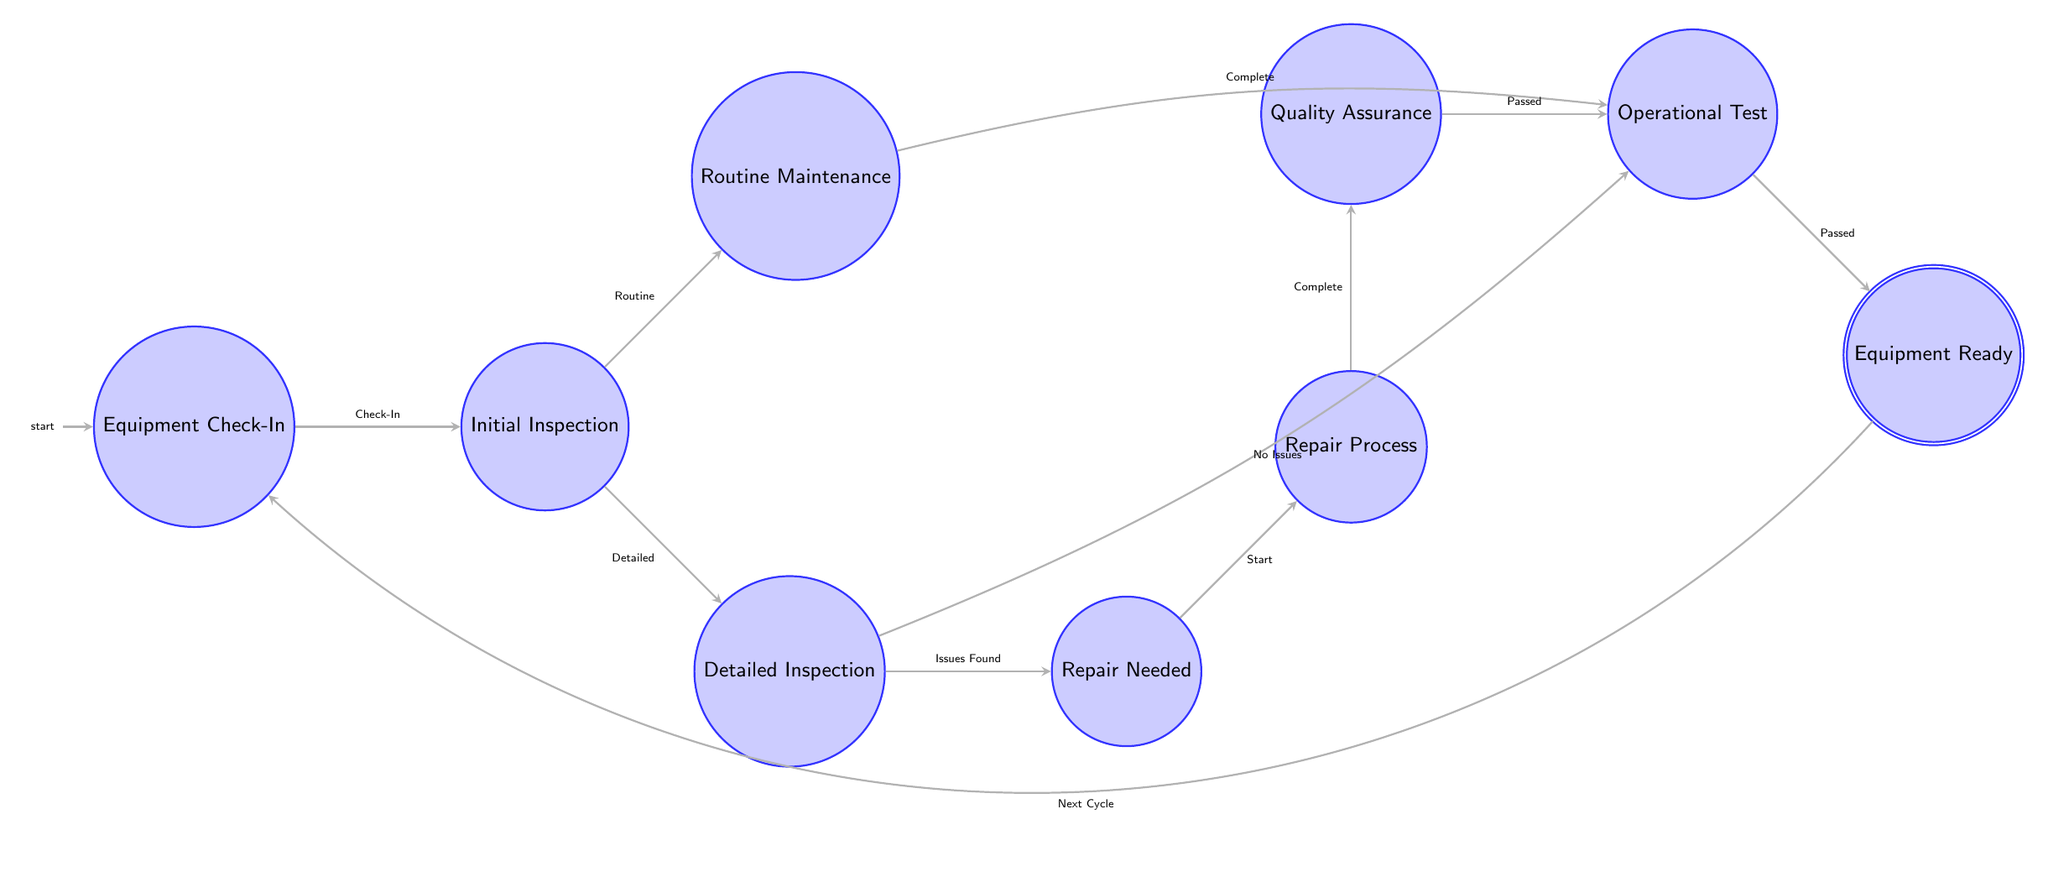What is the first state in the equipment maintenance schedule? The first state is labeled "Equipment Check-In," which is where the process begins according to the diagram.
Answer: Equipment Check-In How many states are there in total? By counting each distinct state in the diagram, including the starting and accepting states, we find that there are nine states.
Answer: Nine What transition occurs after "Routine Maintenance"? The transition that occurs after "Routine Maintenance" is labeled "Complete," which leads to the "Operational Test" state.
Answer: Operational Test What state does "Repair Process" lead to? The "Repair Process" leads to the state "Quality Assurance," as indicated by the transition from one to the other.
Answer: Quality Assurance What are the two potential outcomes after "Detailed Inspection"? After "Detailed Inspection," the possible outcomes are "Repair Needed" and "Operational Test," depending on whether issues were found or not.
Answer: Repair Needed, Operational Test Which state is reached after the "Operational Test" is complete? After the "Operational Test" is complete, the next state reached is "Equipment Ready," as shown in the transition line to the acceptance state.
Answer: Equipment Ready If an issue is found during "Detailed Inspection," what state is entered next? If there are issues found during the "Detailed Inspection," the next state to be entered is "Repair Needed," leading into the repair process.
Answer: Repair Needed What is the purpose of the "Quality Assurance" state? The purpose of the "Quality Assurance" state is to ensure that whatever repairs or maintenance has been conducted meets the required standards before moving to the next state.
Answer: To ensure standards are met In which state does the maintenance cycle return to start again? The maintenance cycle returns to the "Equipment Check-In" state once it reaches "Equipment Ready," completing the cycle.
Answer: Equipment Check-In 